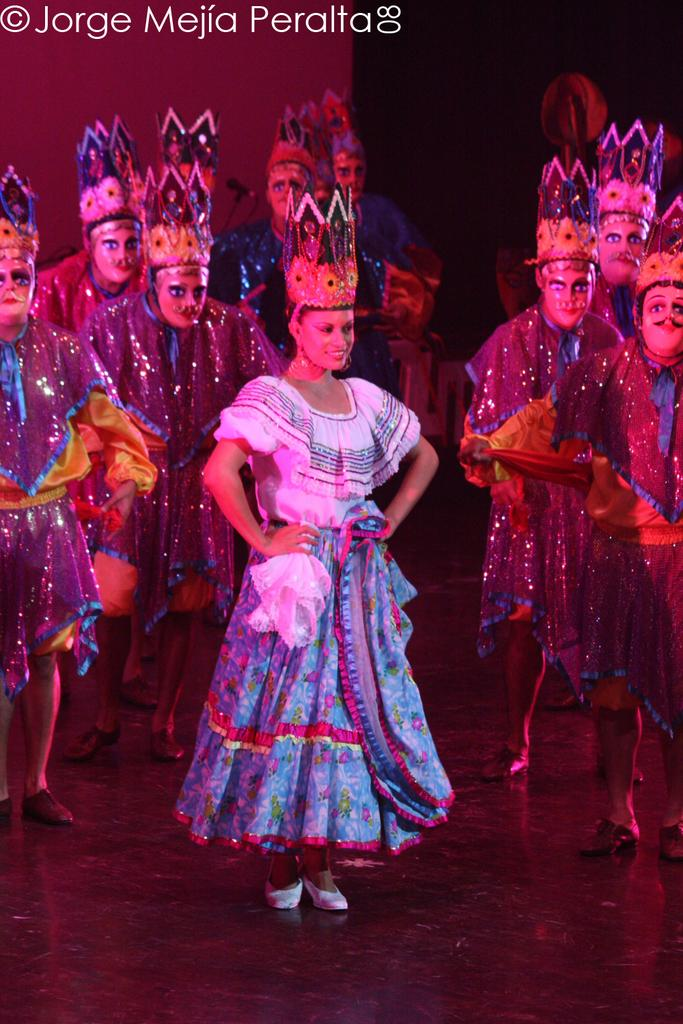What are the persons in the image wearing? The persons in the image are wearing costumes. What is the surface on which the persons are standing? The persons are standing on the floor. What colors can be seen in the background of the image? The background of the image is red and black in color. What type of crack is visible in the image? There is no crack present in the image. What is the cause of the loss experienced by the persons in the image? There is no indication of loss in the image; the persons are wearing costumes and standing on the floor. 